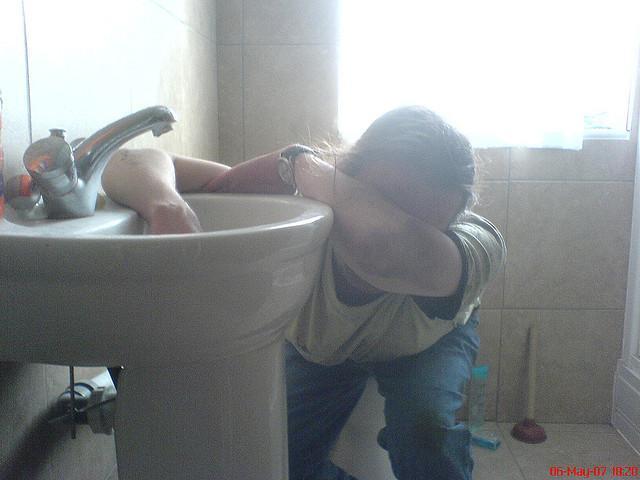How many cows are walking in the road?
Give a very brief answer. 0. 